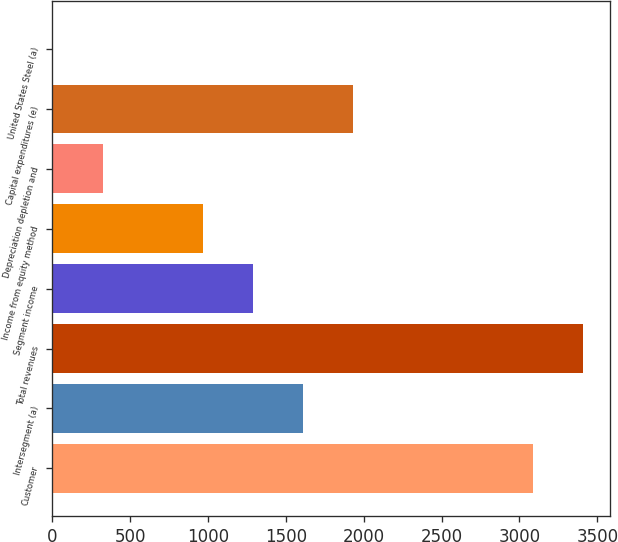Convert chart. <chart><loc_0><loc_0><loc_500><loc_500><bar_chart><fcel>Customer<fcel>Intersegment (a)<fcel>Total revenues<fcel>Segment income<fcel>Income from equity method<fcel>Depreciation depletion and<fcel>Capital expenditures (e)<fcel>United States Steel (a)<nl><fcel>3089<fcel>1608.5<fcel>3409.1<fcel>1288.4<fcel>968.3<fcel>328.1<fcel>1928.6<fcel>8<nl></chart> 